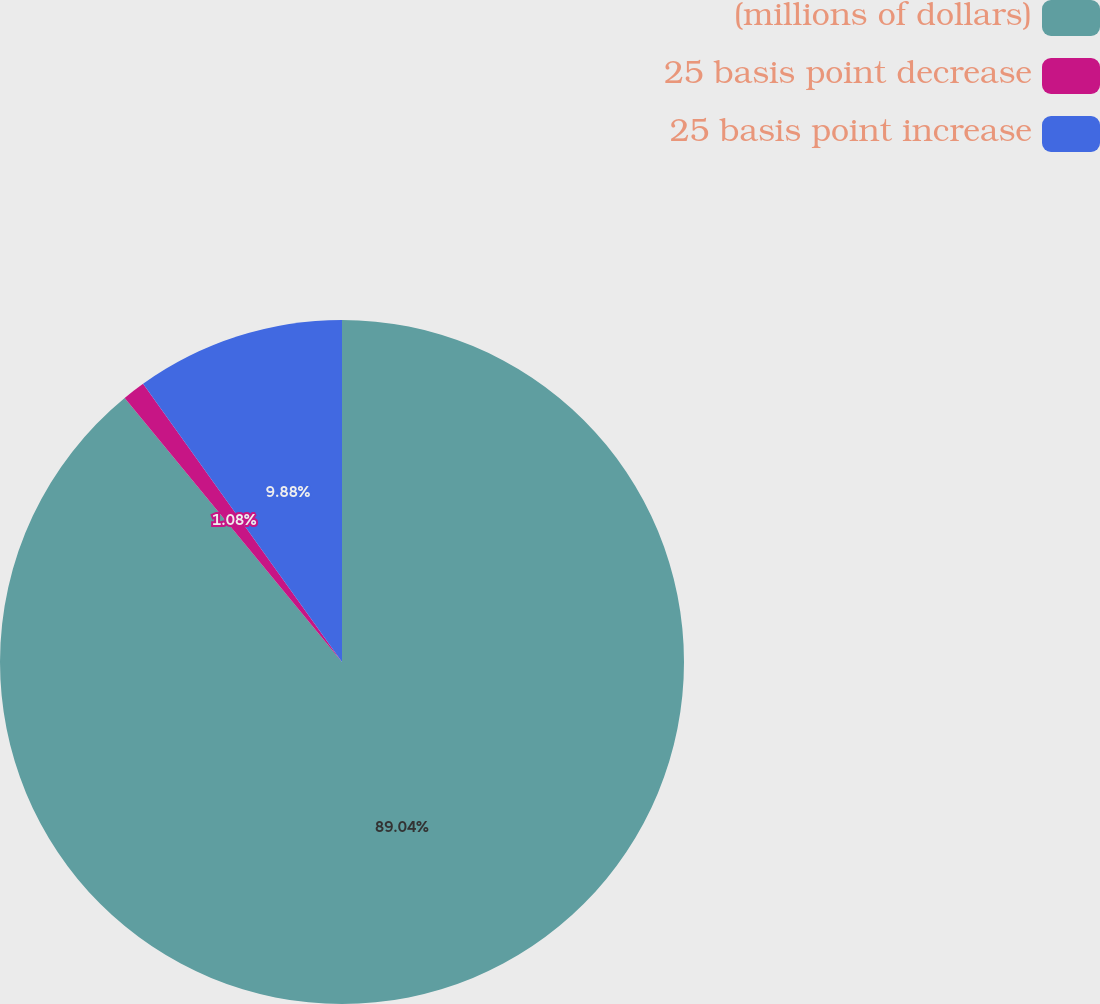Convert chart to OTSL. <chart><loc_0><loc_0><loc_500><loc_500><pie_chart><fcel>(millions of dollars)<fcel>25 basis point decrease<fcel>25 basis point increase<nl><fcel>89.04%<fcel>1.08%<fcel>9.88%<nl></chart> 